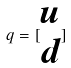<formula> <loc_0><loc_0><loc_500><loc_500>q = [ \begin{matrix} u \\ d \end{matrix} ]</formula> 